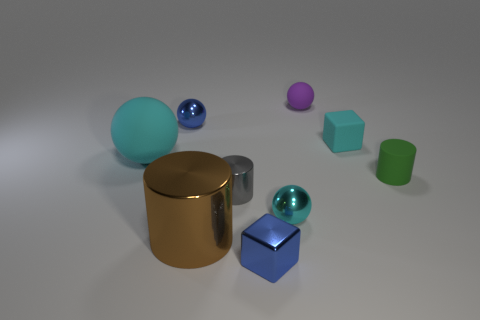Subtract all small balls. How many balls are left? 1 Add 1 yellow metal balls. How many objects exist? 10 Subtract all cyan blocks. How many cyan spheres are left? 2 Subtract all blue spheres. How many spheres are left? 3 Subtract 2 balls. How many balls are left? 2 Subtract all cubes. How many objects are left? 7 Add 8 brown metal things. How many brown metal things are left? 9 Add 2 big purple metal objects. How many big purple metal objects exist? 2 Subtract 1 cyan blocks. How many objects are left? 8 Subtract all yellow balls. Subtract all yellow cubes. How many balls are left? 4 